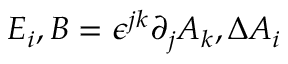Convert formula to latex. <formula><loc_0><loc_0><loc_500><loc_500>E _ { i } , B = \epsilon ^ { j k } \partial _ { j } A _ { k } , \Delta A _ { i }</formula> 